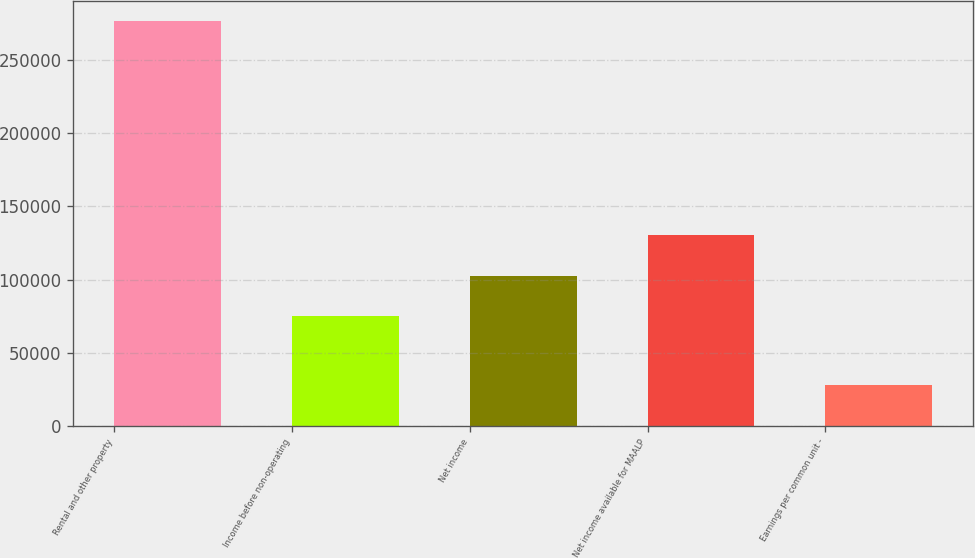Convert chart to OTSL. <chart><loc_0><loc_0><loc_500><loc_500><bar_chart><fcel>Rental and other property<fcel>Income before non-operating<fcel>Net income<fcel>Net income available for MAALP<fcel>Earnings per common unit -<nl><fcel>276898<fcel>74823<fcel>102513<fcel>130202<fcel>27690.8<nl></chart> 